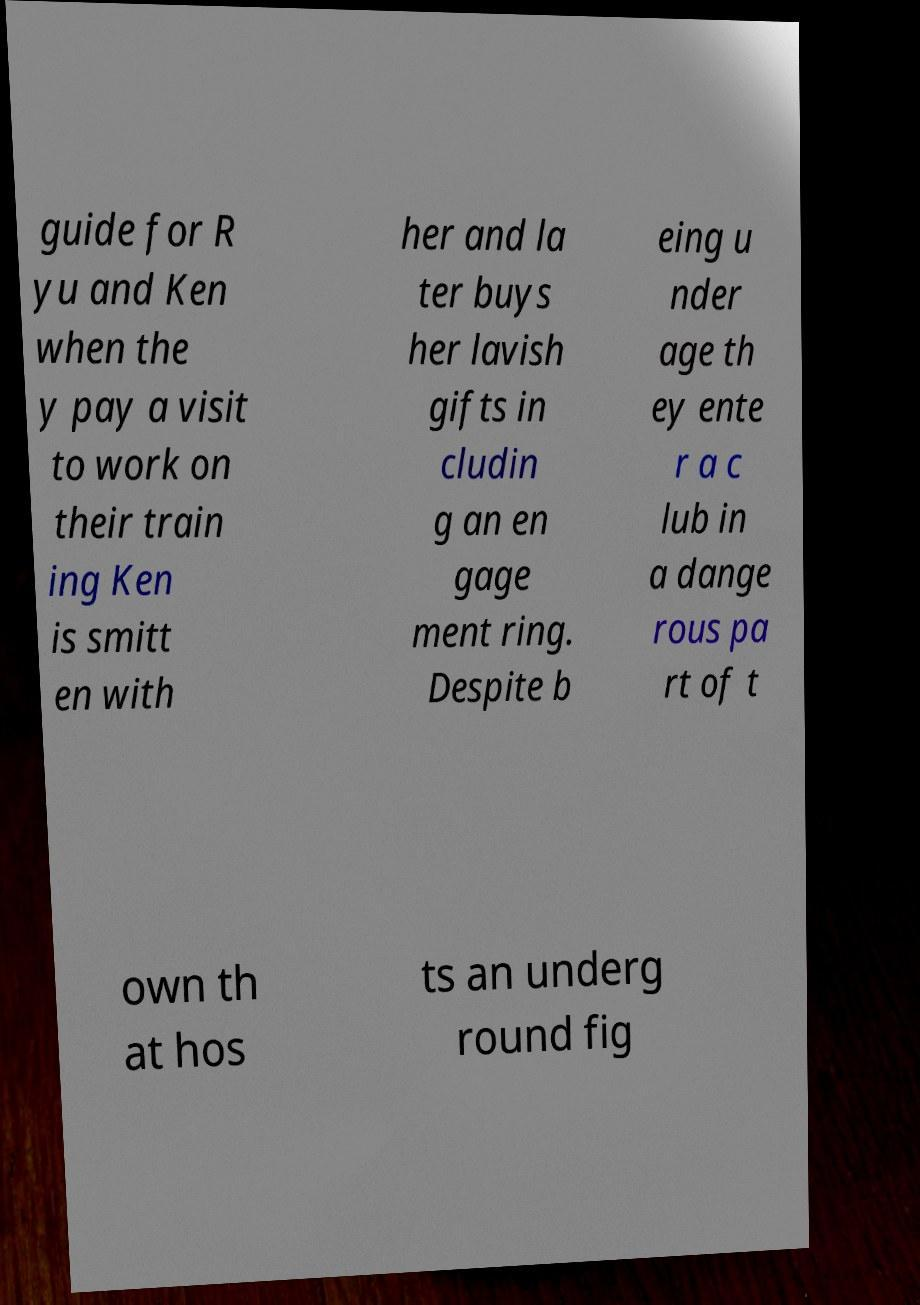Please identify and transcribe the text found in this image. guide for R yu and Ken when the y pay a visit to work on their train ing Ken is smitt en with her and la ter buys her lavish gifts in cludin g an en gage ment ring. Despite b eing u nder age th ey ente r a c lub in a dange rous pa rt of t own th at hos ts an underg round fig 